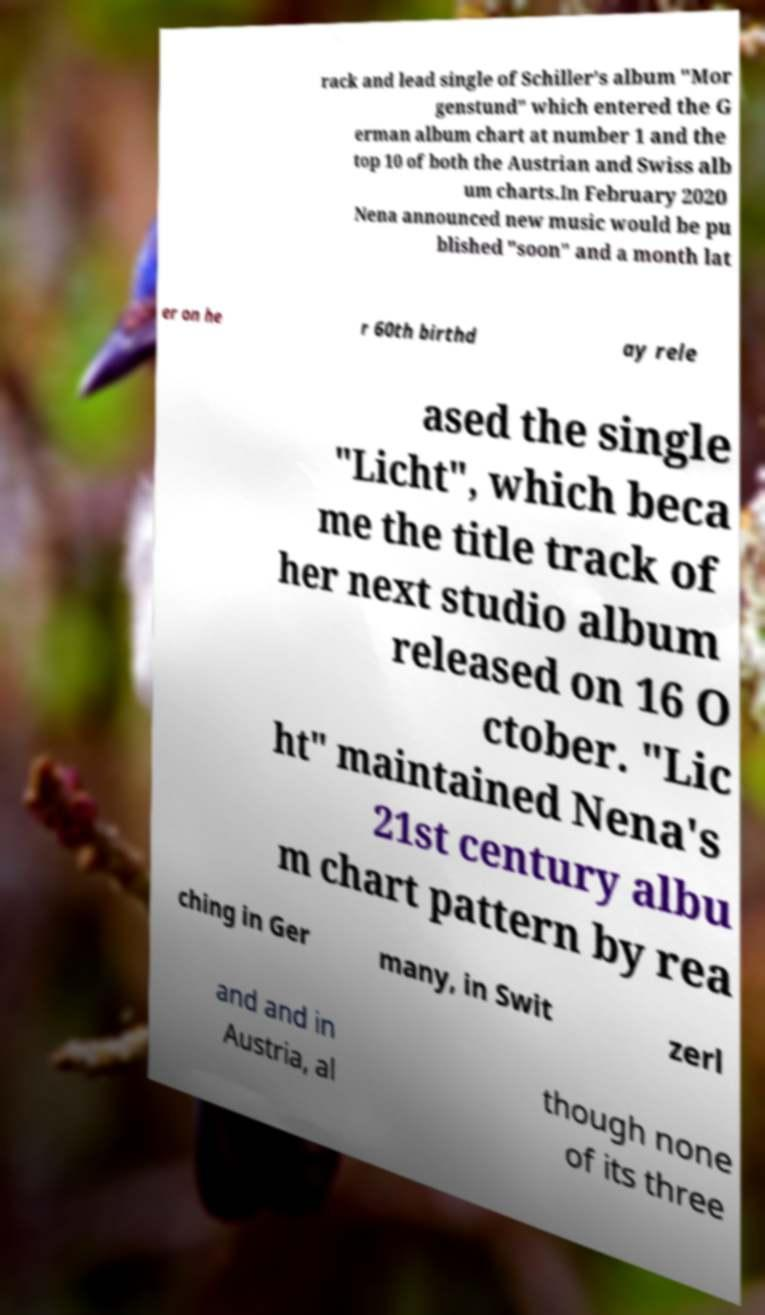I need the written content from this picture converted into text. Can you do that? rack and lead single of Schiller's album "Mor genstund" which entered the G erman album chart at number 1 and the top 10 of both the Austrian and Swiss alb um charts.In February 2020 Nena announced new music would be pu blished "soon" and a month lat er on he r 60th birthd ay rele ased the single "Licht", which beca me the title track of her next studio album released on 16 O ctober. "Lic ht" maintained Nena's 21st century albu m chart pattern by rea ching in Ger many, in Swit zerl and and in Austria, al though none of its three 